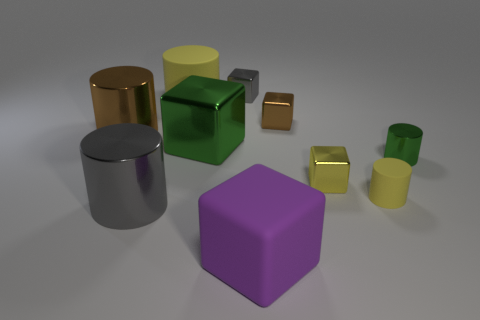Subtract 1 blocks. How many blocks are left? 4 Subtract all cyan cylinders. Subtract all purple blocks. How many cylinders are left? 5 Add 8 rubber blocks. How many rubber blocks exist? 9 Subtract 0 red balls. How many objects are left? 10 Subtract all big cylinders. Subtract all cyan blocks. How many objects are left? 7 Add 1 large gray metal cylinders. How many large gray metal cylinders are left? 2 